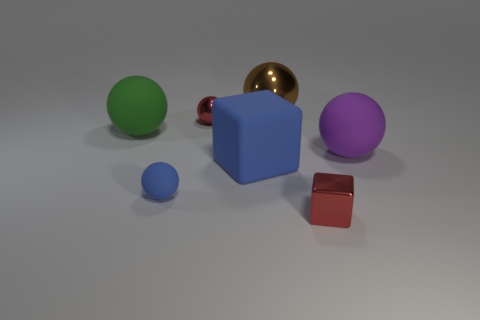Comparing the textures of the objects, do any of them stand out? The textures in the image are not overly pronounced, but the golden sphere stands out due to its high reflective surface, indicating a smoother and possibly metallic texture in contrast to the matte finish of the other objects.  Could the texture of the golden sphere have any specific implications? The reflective texture could imply that the golden sphere is likely metallic, and its polished surface might suggest it's intended to be decorative or could serve a functional purpose in reflecting light or its surroundings. 